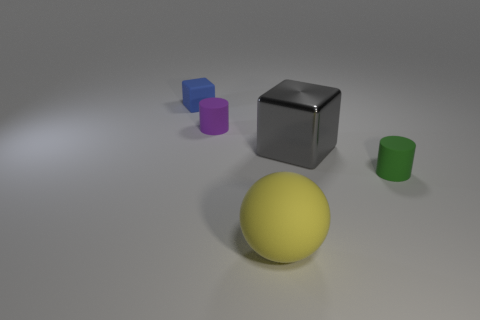Is there any other thing that is made of the same material as the big gray thing?
Provide a short and direct response. No. Are any blue matte things visible?
Give a very brief answer. Yes. There is a big rubber thing; is its color the same as the cube in front of the matte block?
Offer a very short reply. No. What is the size of the blue rubber object to the left of the matte cylinder to the right of the large thing that is in front of the small green cylinder?
Provide a succinct answer. Small. What number of things are blue matte cubes or tiny rubber cylinders right of the small purple thing?
Offer a very short reply. 2. What color is the rubber ball?
Offer a terse response. Yellow. What is the color of the object in front of the tiny green cylinder?
Ensure brevity in your answer.  Yellow. How many big metal objects are behind the small cylinder that is right of the big cube?
Your response must be concise. 1. Do the blue matte object and the cylinder that is right of the purple cylinder have the same size?
Provide a succinct answer. Yes. Are there any other rubber objects that have the same size as the purple object?
Your response must be concise. Yes. 